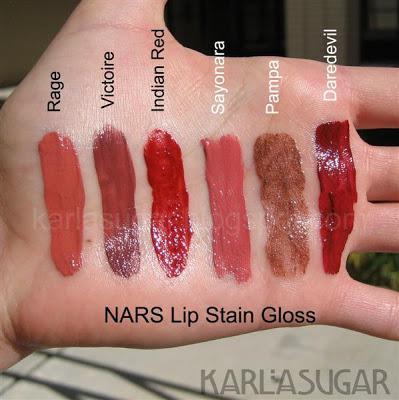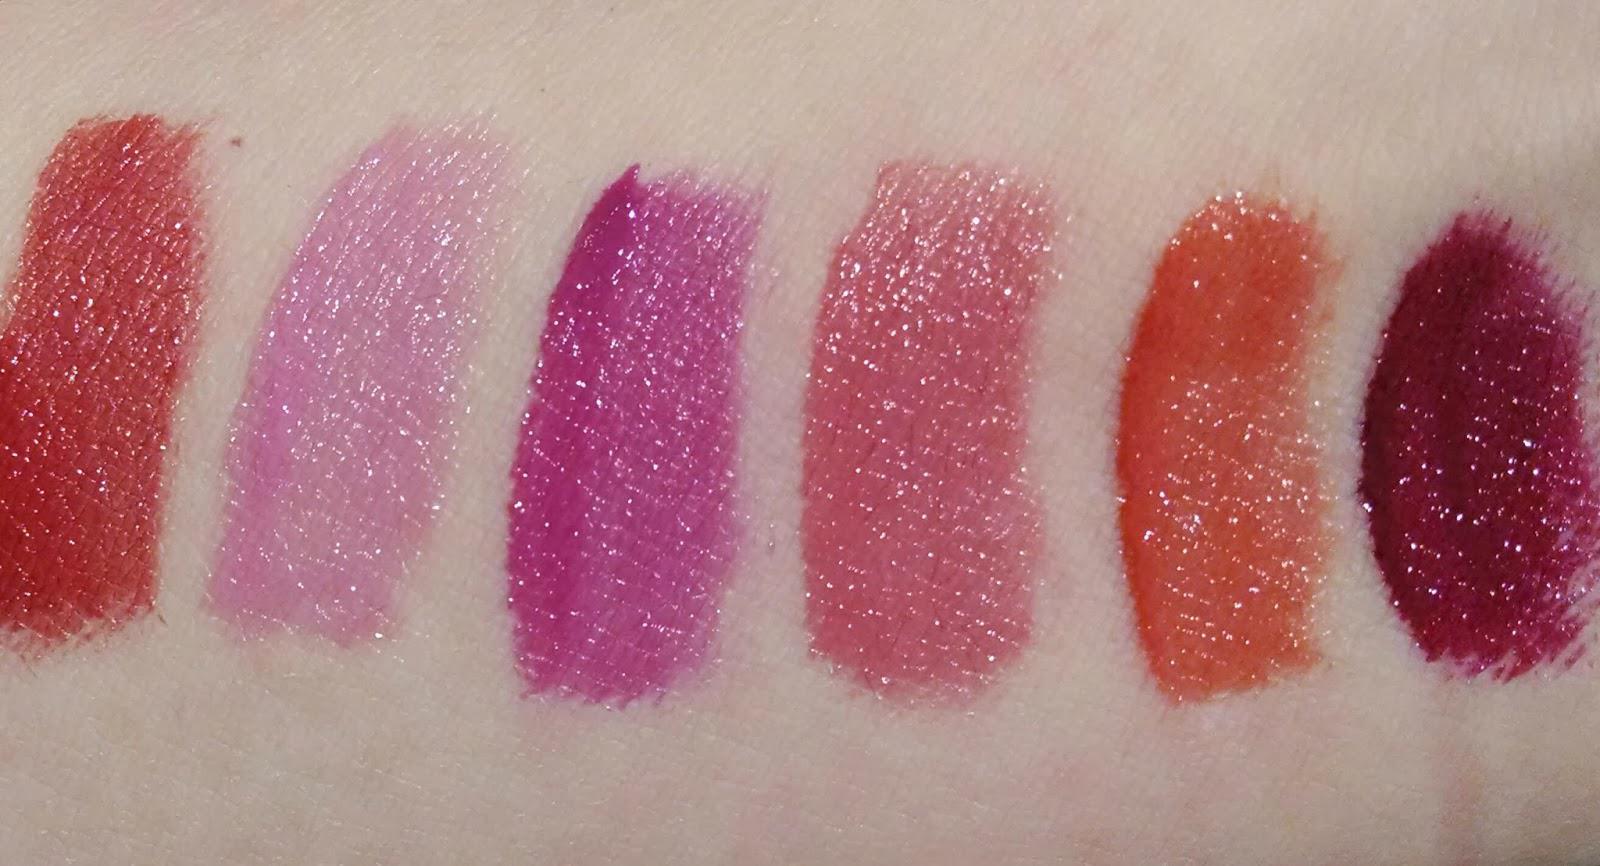The first image is the image on the left, the second image is the image on the right. For the images displayed, is the sentence "A pair of lips is visible in the right image" factually correct? Answer yes or no. No. The first image is the image on the left, the second image is the image on the right. For the images displayed, is the sentence "Right image shows one pair of tinted lips." factually correct? Answer yes or no. No. 